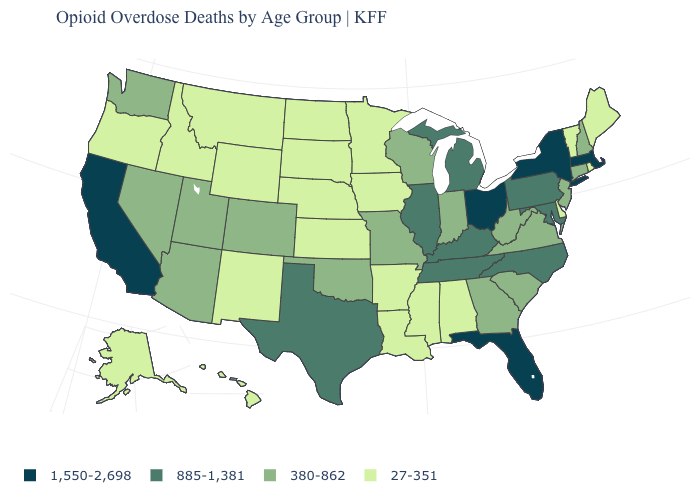Among the states that border North Carolina , does Georgia have the lowest value?
Concise answer only. Yes. What is the value of Ohio?
Short answer required. 1,550-2,698. What is the value of North Carolina?
Keep it brief. 885-1,381. Among the states that border Iowa , which have the lowest value?
Short answer required. Minnesota, Nebraska, South Dakota. How many symbols are there in the legend?
Be succinct. 4. Name the states that have a value in the range 380-862?
Answer briefly. Arizona, Colorado, Connecticut, Georgia, Indiana, Missouri, Nevada, New Hampshire, New Jersey, Oklahoma, South Carolina, Utah, Virginia, Washington, West Virginia, Wisconsin. Does the first symbol in the legend represent the smallest category?
Write a very short answer. No. Which states hav the highest value in the MidWest?
Short answer required. Ohio. What is the highest value in the USA?
Write a very short answer. 1,550-2,698. Does the first symbol in the legend represent the smallest category?
Give a very brief answer. No. Does Arizona have the highest value in the West?
Answer briefly. No. What is the lowest value in the West?
Quick response, please. 27-351. Does Washington have the lowest value in the USA?
Short answer required. No. What is the lowest value in states that border Ohio?
Give a very brief answer. 380-862. 